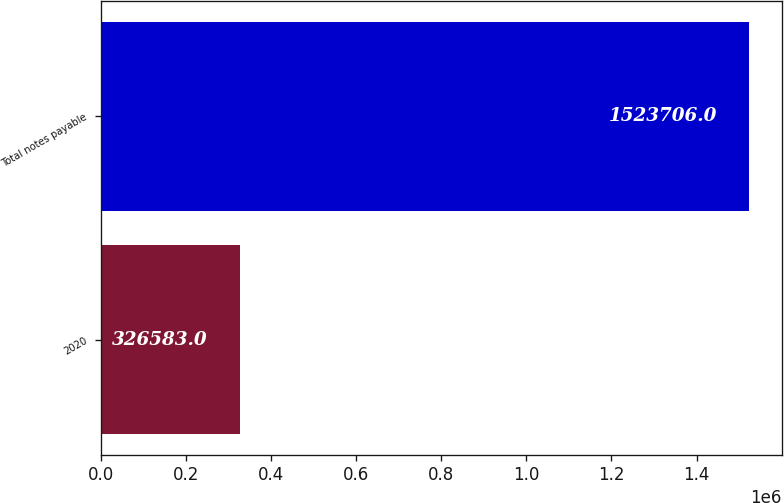Convert chart. <chart><loc_0><loc_0><loc_500><loc_500><bar_chart><fcel>2020<fcel>Total notes payable<nl><fcel>326583<fcel>1.52371e+06<nl></chart> 